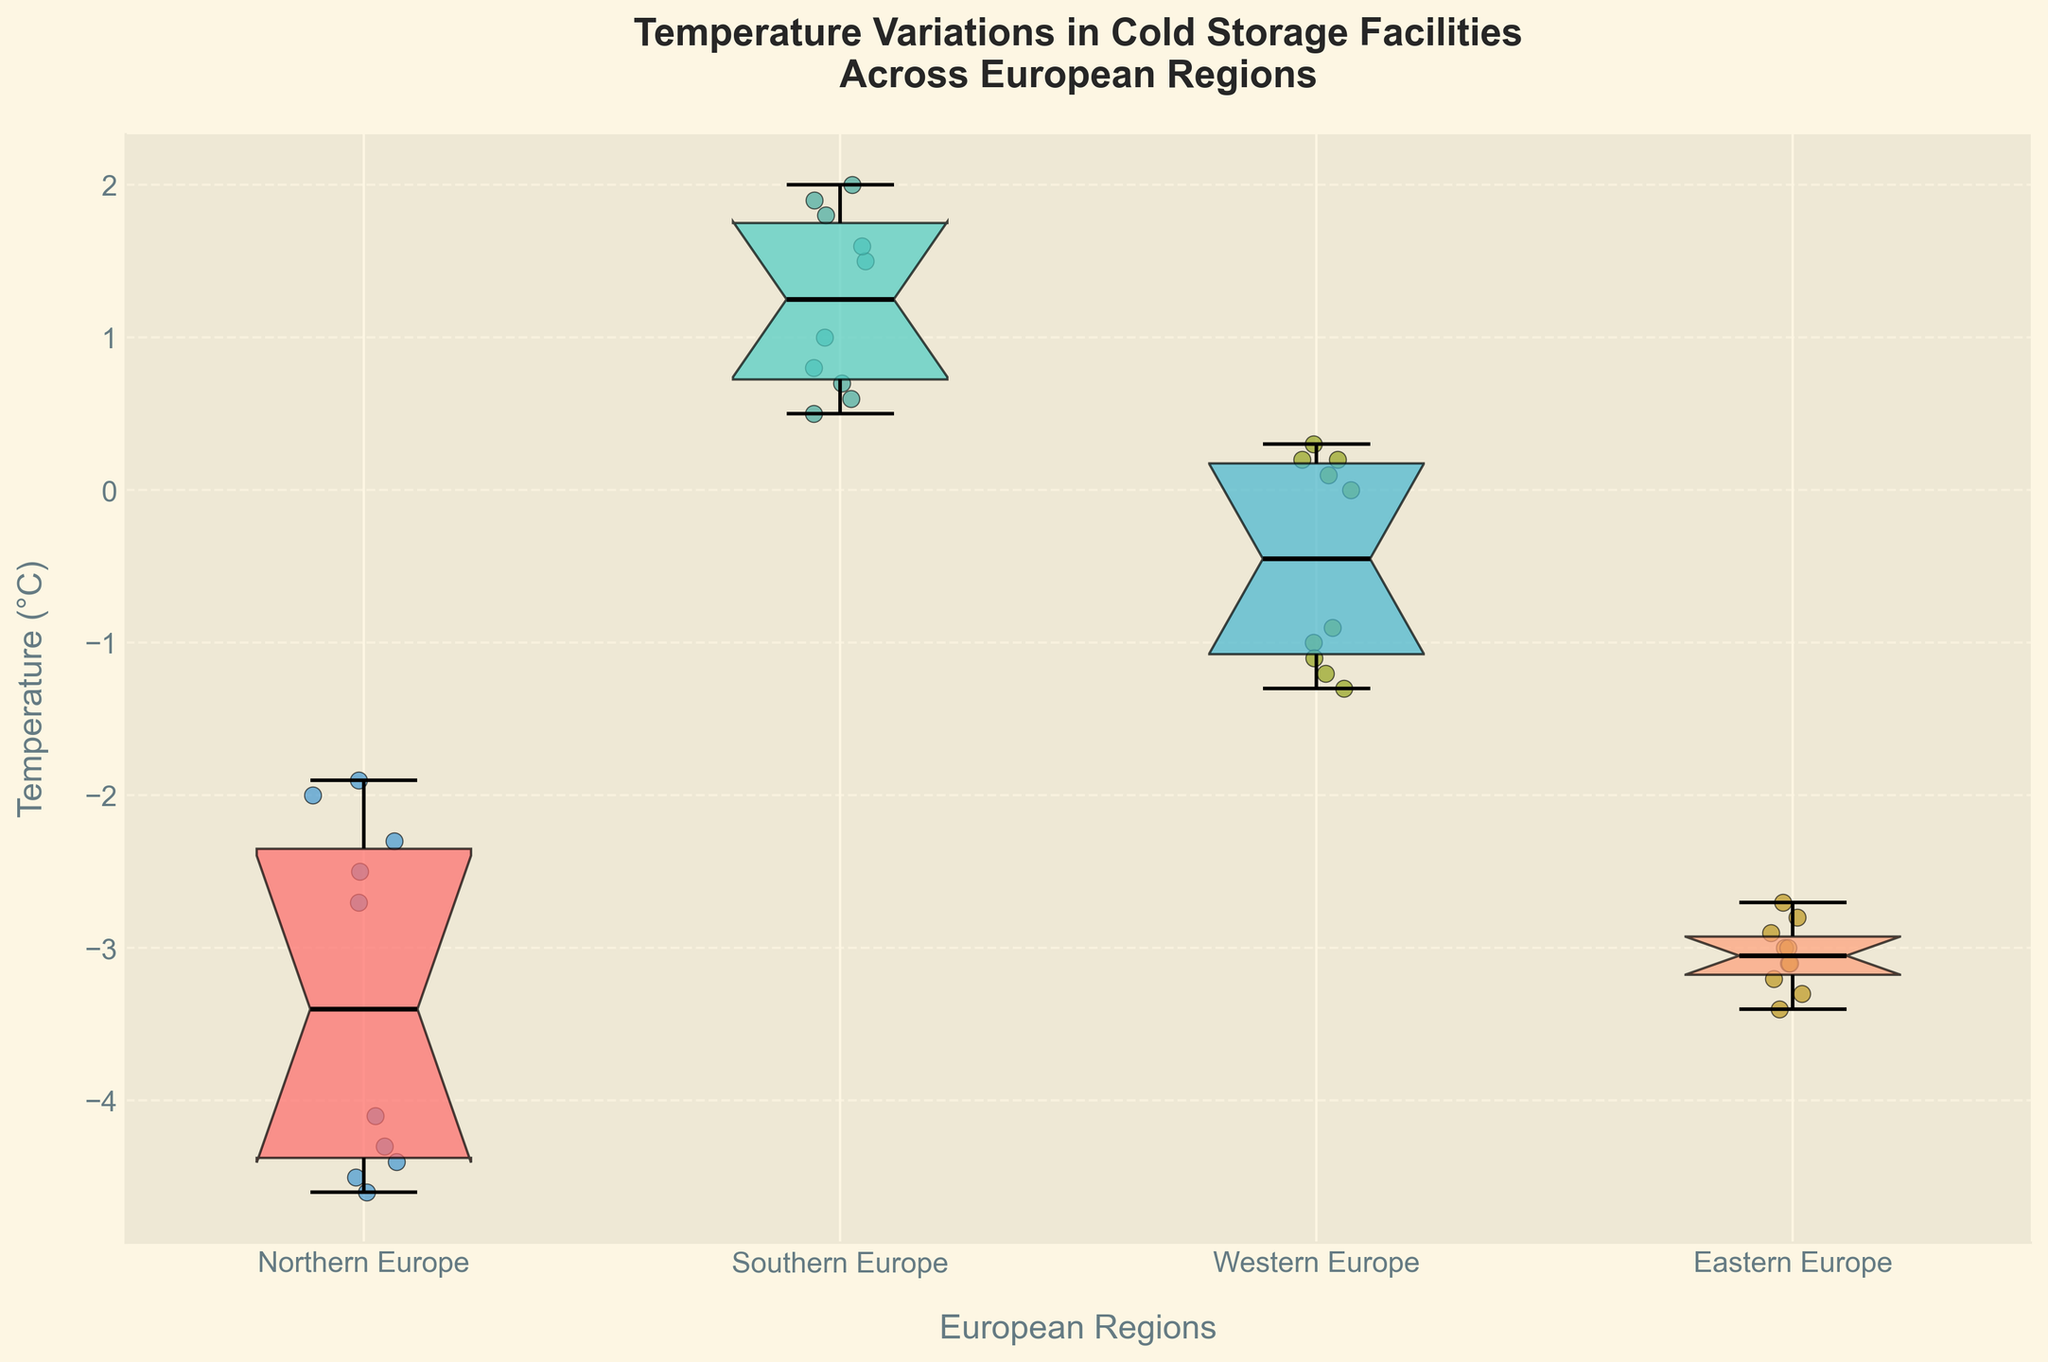What is the title of the notched box plot? The title is prominently displayed at the top of the figure.
Answer: Temperature Variations in Cold Storage Facilities Across European Regions What are the labeled regions on the x-axis? The labels on the x-axis correspond to different European regions.
Answer: Northern Europe, Southern Europe, Western Europe, Eastern Europe Which region has the highest median temperature? The notches in the box plots represent the median values. The region with the highest median will have the highest notch.
Answer: Southern Europe Which region has the lowest median temperature? The notches in the box plots represent the median values. The region with the lowest median will have the lowest notch.
Answer: Northern Europe What are the temperature ranges for Northern Europe and Southern Europe? The temperature range is represented by the whiskers of the box plot. Locate the corresponding ends of the whiskers for both regions.
Answer: Northern Europe: -4.6°C to -1.9°C, Southern Europe: 0.5°C to 2.0°C Is there any overlap in temperatures between Western Europe and Eastern Europe? Overlapping occurs if the whiskers or boxes intersect between groups.
Answer: Yes, there is an overlap How many data points are in the Northern Europe region? The number of data points can be counted by observing the scatter points overlaying the box plot for the Northern Europe region.
Answer: 10 data points Between which two regions is the temperature variation the highest? The height of the boxes and the length of the whiskers indicate the variation. The region pair with the most significant difference will have the highest levels.
Answer: Northern Europe and Southern Europe Which region appears to have the most consistent temperature readings? The shortest boxes and whiskers indicator represent the consistency of readings.
Answer: Western Europe 